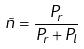<formula> <loc_0><loc_0><loc_500><loc_500>\tilde { n } = \frac { P _ { r } } { P _ { r } + P _ { l } }</formula> 